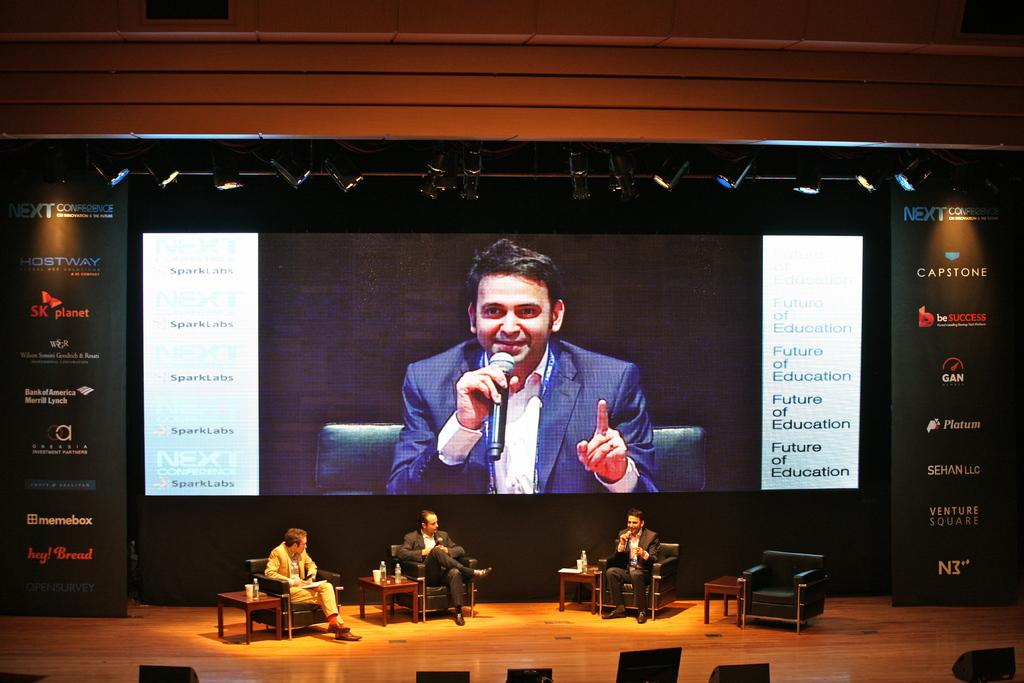<image>
Describe the image concisely. Three people are on stage at an event sponsored by Bank of America, among many others. 